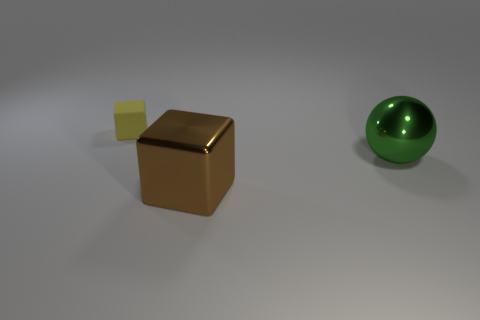Is there anything else that is the same size as the yellow rubber cube?
Offer a very short reply. No. How many yellow blocks are there?
Your answer should be compact. 1. Do the tiny yellow object and the shiny object that is left of the green shiny thing have the same shape?
Give a very brief answer. Yes. There is a metallic ball behind the big brown thing; what size is it?
Keep it short and to the point. Large. What is the tiny object made of?
Ensure brevity in your answer.  Rubber. Do the metal object to the right of the brown metallic cube and the tiny yellow rubber object have the same shape?
Your response must be concise. No. Are there any purple rubber cubes that have the same size as the green ball?
Your response must be concise. No. Are there any rubber things that are on the left side of the object left of the block that is right of the yellow thing?
Offer a very short reply. No. Does the tiny matte block have the same color as the cube in front of the metallic ball?
Your answer should be compact. No. There is a cube in front of the thing on the left side of the cube on the right side of the tiny object; what is it made of?
Make the answer very short. Metal. 